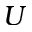Convert formula to latex. <formula><loc_0><loc_0><loc_500><loc_500>U</formula> 